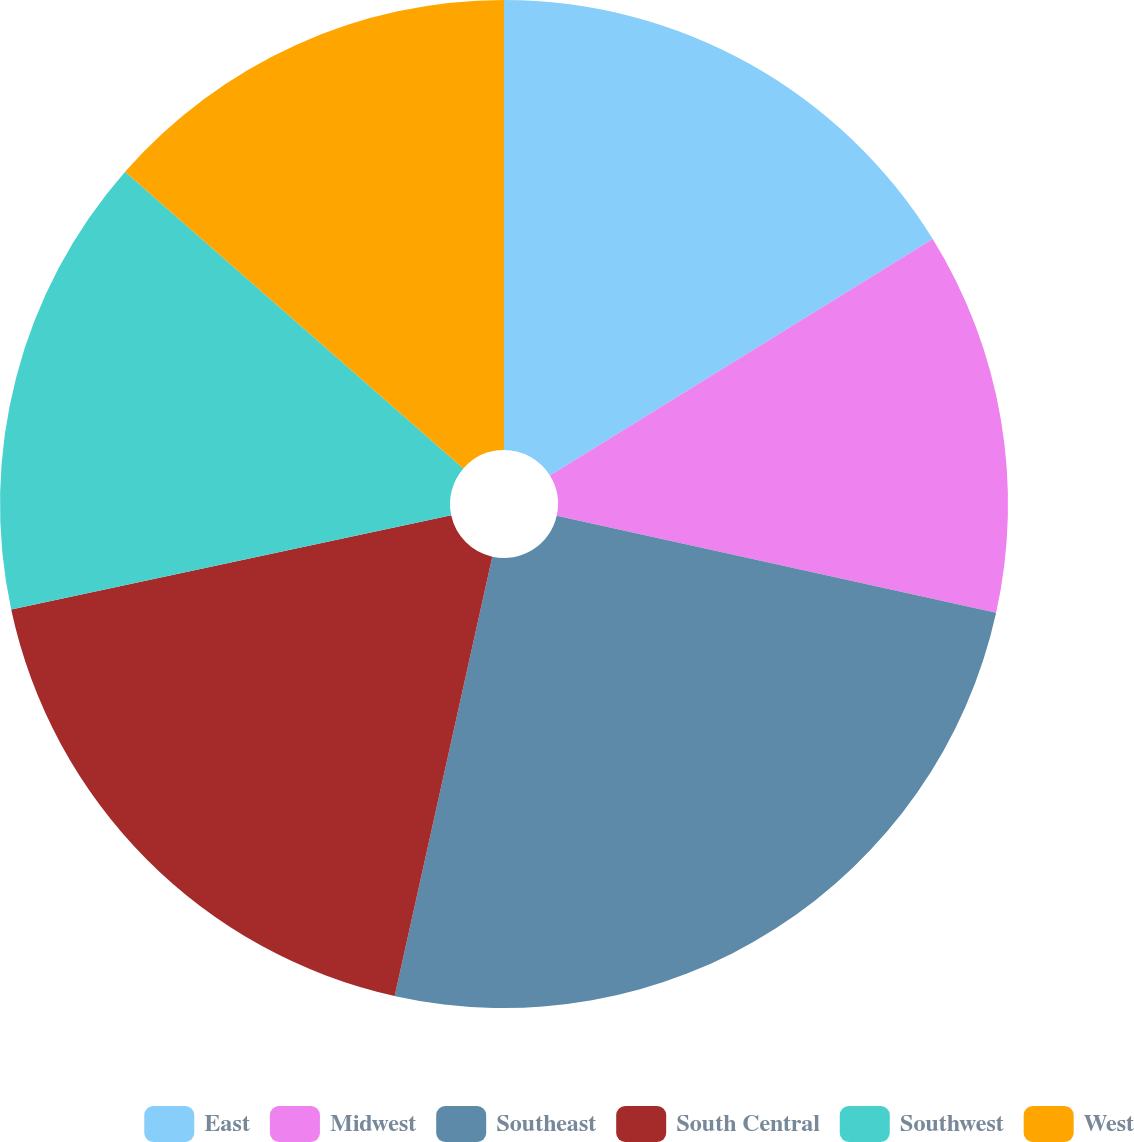Convert chart. <chart><loc_0><loc_0><loc_500><loc_500><pie_chart><fcel>East<fcel>Midwest<fcel>Southeast<fcel>South Central<fcel>Southwest<fcel>West<nl><fcel>16.19%<fcel>12.27%<fcel>25.02%<fcel>18.16%<fcel>14.82%<fcel>13.54%<nl></chart> 